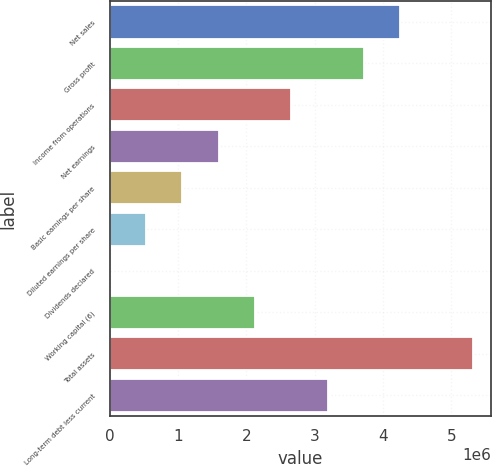<chart> <loc_0><loc_0><loc_500><loc_500><bar_chart><fcel>Net sales<fcel>Gross profit<fcel>Income from operations<fcel>Net earnings<fcel>Basic earnings per share<fcel>Diluted earnings per share<fcel>Dividends declared<fcel>Working capital (6)<fcel>Total assets<fcel>Long-term debt less current<nl><fcel>4.25553e+06<fcel>3.72359e+06<fcel>2.65971e+06<fcel>1.59583e+06<fcel>1.06388e+06<fcel>531942<fcel>0.47<fcel>2.12777e+06<fcel>5.31942e+06<fcel>3.19165e+06<nl></chart> 